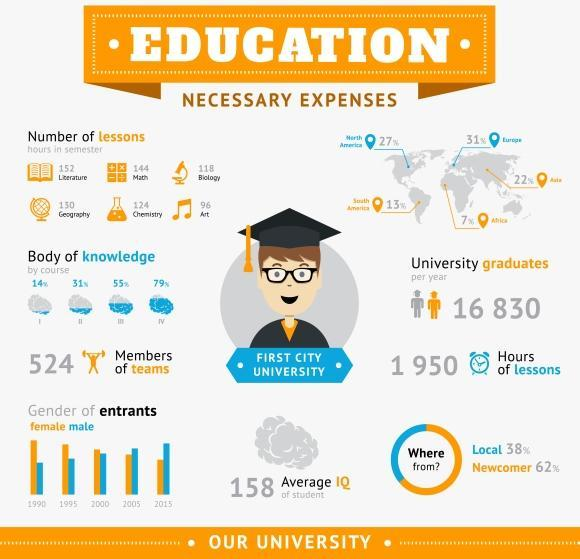Which year has the third lowest number of female entrants?
Answer the question with a short phrase. 2000 How many topics are course streams are offered by the first city university? 6 Which year has the second lowest figure in male entrants ? 1995 